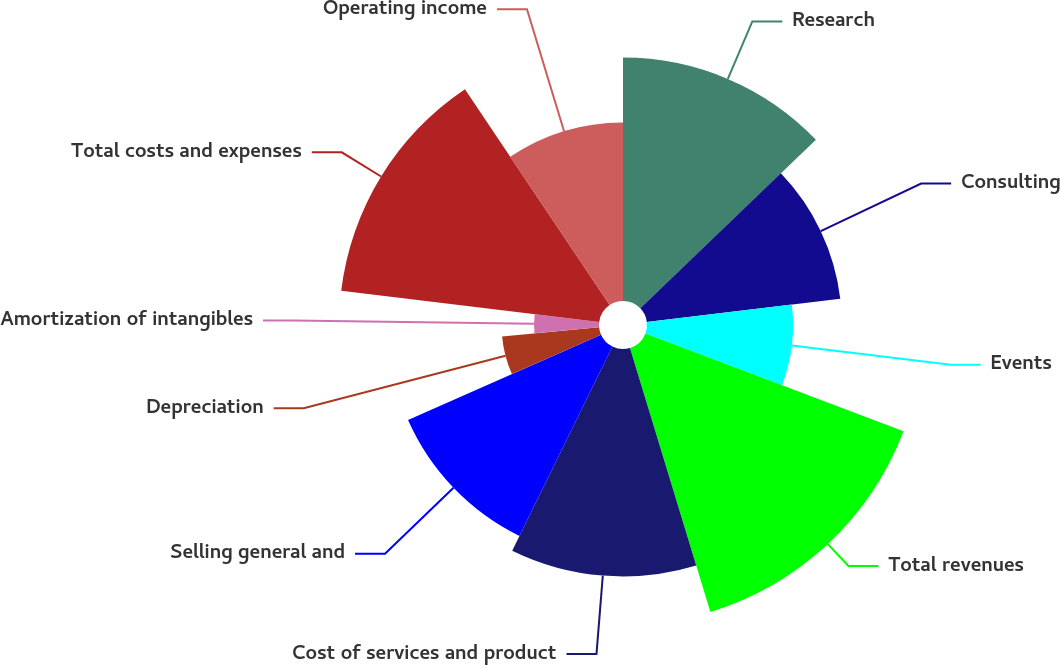Convert chart. <chart><loc_0><loc_0><loc_500><loc_500><pie_chart><fcel>Research<fcel>Consulting<fcel>Events<fcel>Total revenues<fcel>Cost of services and product<fcel>Selling general and<fcel>Depreciation<fcel>Amortization of intangibles<fcel>Total costs and expenses<fcel>Operating income<nl><fcel>12.82%<fcel>10.26%<fcel>7.69%<fcel>14.53%<fcel>11.97%<fcel>11.11%<fcel>5.13%<fcel>3.42%<fcel>13.68%<fcel>9.4%<nl></chart> 